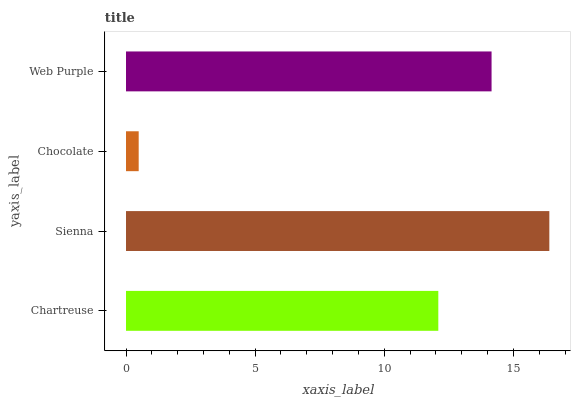Is Chocolate the minimum?
Answer yes or no. Yes. Is Sienna the maximum?
Answer yes or no. Yes. Is Sienna the minimum?
Answer yes or no. No. Is Chocolate the maximum?
Answer yes or no. No. Is Sienna greater than Chocolate?
Answer yes or no. Yes. Is Chocolate less than Sienna?
Answer yes or no. Yes. Is Chocolate greater than Sienna?
Answer yes or no. No. Is Sienna less than Chocolate?
Answer yes or no. No. Is Web Purple the high median?
Answer yes or no. Yes. Is Chartreuse the low median?
Answer yes or no. Yes. Is Chartreuse the high median?
Answer yes or no. No. Is Chocolate the low median?
Answer yes or no. No. 